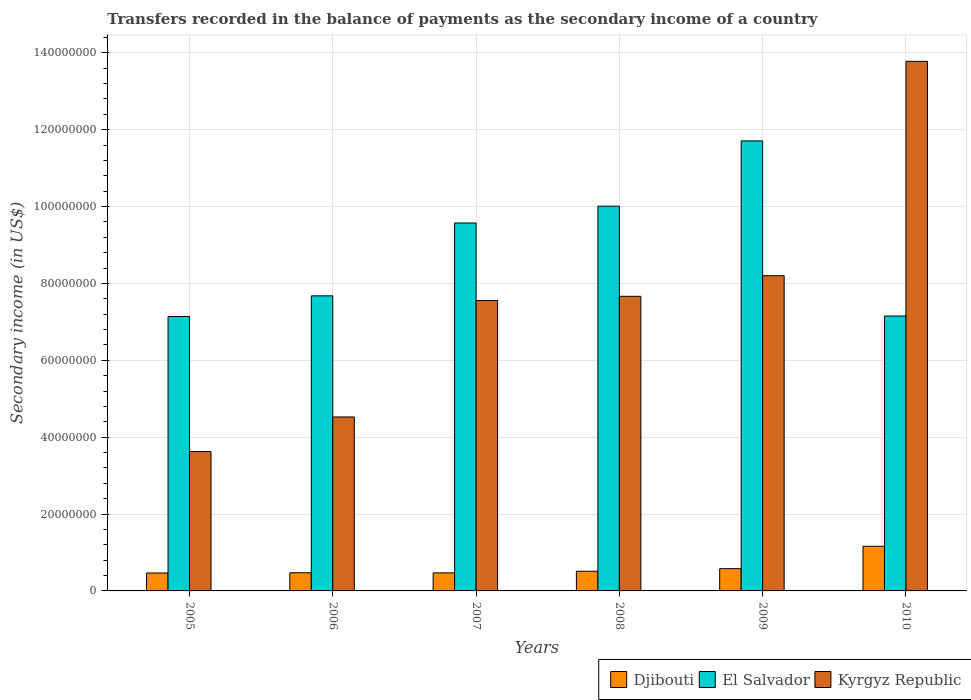How many different coloured bars are there?
Make the answer very short. 3. Are the number of bars on each tick of the X-axis equal?
Your answer should be compact. Yes. How many bars are there on the 1st tick from the right?
Ensure brevity in your answer.  3. What is the label of the 1st group of bars from the left?
Your answer should be compact. 2005. What is the secondary income of in Djibouti in 2007?
Give a very brief answer. 4.70e+06. Across all years, what is the maximum secondary income of in El Salvador?
Ensure brevity in your answer.  1.17e+08. Across all years, what is the minimum secondary income of in El Salvador?
Offer a very short reply. 7.14e+07. What is the total secondary income of in Djibouti in the graph?
Provide a short and direct response. 3.66e+07. What is the difference between the secondary income of in Kyrgyz Republic in 2007 and that in 2010?
Your answer should be very brief. -6.22e+07. What is the difference between the secondary income of in El Salvador in 2008 and the secondary income of in Djibouti in 2007?
Give a very brief answer. 9.54e+07. What is the average secondary income of in Djibouti per year?
Your answer should be compact. 6.10e+06. In the year 2006, what is the difference between the secondary income of in El Salvador and secondary income of in Kyrgyz Republic?
Your response must be concise. 3.15e+07. What is the ratio of the secondary income of in El Salvador in 2007 to that in 2008?
Give a very brief answer. 0.96. Is the difference between the secondary income of in El Salvador in 2005 and 2006 greater than the difference between the secondary income of in Kyrgyz Republic in 2005 and 2006?
Give a very brief answer. Yes. What is the difference between the highest and the second highest secondary income of in Kyrgyz Republic?
Provide a short and direct response. 5.58e+07. What is the difference between the highest and the lowest secondary income of in Djibouti?
Offer a terse response. 6.95e+06. In how many years, is the secondary income of in Djibouti greater than the average secondary income of in Djibouti taken over all years?
Offer a very short reply. 1. Is the sum of the secondary income of in El Salvador in 2005 and 2010 greater than the maximum secondary income of in Djibouti across all years?
Offer a terse response. Yes. What does the 3rd bar from the left in 2006 represents?
Your answer should be compact. Kyrgyz Republic. What does the 2nd bar from the right in 2005 represents?
Your response must be concise. El Salvador. Are all the bars in the graph horizontal?
Your answer should be very brief. No. How many years are there in the graph?
Provide a succinct answer. 6. How many legend labels are there?
Make the answer very short. 3. How are the legend labels stacked?
Give a very brief answer. Horizontal. What is the title of the graph?
Ensure brevity in your answer.  Transfers recorded in the balance of payments as the secondary income of a country. Does "Kuwait" appear as one of the legend labels in the graph?
Give a very brief answer. No. What is the label or title of the X-axis?
Your answer should be compact. Years. What is the label or title of the Y-axis?
Give a very brief answer. Secondary income (in US$). What is the Secondary income (in US$) in Djibouti in 2005?
Your answer should be very brief. 4.67e+06. What is the Secondary income (in US$) of El Salvador in 2005?
Your answer should be very brief. 7.14e+07. What is the Secondary income (in US$) in Kyrgyz Republic in 2005?
Provide a succinct answer. 3.63e+07. What is the Secondary income (in US$) in Djibouti in 2006?
Your answer should be compact. 4.73e+06. What is the Secondary income (in US$) of El Salvador in 2006?
Your answer should be compact. 7.68e+07. What is the Secondary income (in US$) in Kyrgyz Republic in 2006?
Your answer should be very brief. 4.53e+07. What is the Secondary income (in US$) in Djibouti in 2007?
Provide a short and direct response. 4.70e+06. What is the Secondary income (in US$) of El Salvador in 2007?
Your answer should be compact. 9.57e+07. What is the Secondary income (in US$) in Kyrgyz Republic in 2007?
Your answer should be compact. 7.56e+07. What is the Secondary income (in US$) of Djibouti in 2008?
Provide a succinct answer. 5.12e+06. What is the Secondary income (in US$) of El Salvador in 2008?
Make the answer very short. 1.00e+08. What is the Secondary income (in US$) in Kyrgyz Republic in 2008?
Provide a succinct answer. 7.67e+07. What is the Secondary income (in US$) in Djibouti in 2009?
Your response must be concise. 5.79e+06. What is the Secondary income (in US$) of El Salvador in 2009?
Offer a very short reply. 1.17e+08. What is the Secondary income (in US$) in Kyrgyz Republic in 2009?
Your response must be concise. 8.20e+07. What is the Secondary income (in US$) of Djibouti in 2010?
Provide a short and direct response. 1.16e+07. What is the Secondary income (in US$) in El Salvador in 2010?
Ensure brevity in your answer.  7.15e+07. What is the Secondary income (in US$) in Kyrgyz Republic in 2010?
Provide a short and direct response. 1.38e+08. Across all years, what is the maximum Secondary income (in US$) of Djibouti?
Provide a short and direct response. 1.16e+07. Across all years, what is the maximum Secondary income (in US$) in El Salvador?
Offer a very short reply. 1.17e+08. Across all years, what is the maximum Secondary income (in US$) of Kyrgyz Republic?
Give a very brief answer. 1.38e+08. Across all years, what is the minimum Secondary income (in US$) in Djibouti?
Provide a short and direct response. 4.67e+06. Across all years, what is the minimum Secondary income (in US$) in El Salvador?
Give a very brief answer. 7.14e+07. Across all years, what is the minimum Secondary income (in US$) of Kyrgyz Republic?
Your answer should be very brief. 3.63e+07. What is the total Secondary income (in US$) in Djibouti in the graph?
Make the answer very short. 3.66e+07. What is the total Secondary income (in US$) of El Salvador in the graph?
Your answer should be compact. 5.33e+08. What is the total Secondary income (in US$) in Kyrgyz Republic in the graph?
Your answer should be very brief. 4.54e+08. What is the difference between the Secondary income (in US$) of Djibouti in 2005 and that in 2006?
Provide a short and direct response. -5.63e+04. What is the difference between the Secondary income (in US$) of El Salvador in 2005 and that in 2006?
Provide a short and direct response. -5.38e+06. What is the difference between the Secondary income (in US$) in Kyrgyz Republic in 2005 and that in 2006?
Offer a terse response. -8.99e+06. What is the difference between the Secondary income (in US$) of Djibouti in 2005 and that in 2007?
Provide a succinct answer. -2.81e+04. What is the difference between the Secondary income (in US$) in El Salvador in 2005 and that in 2007?
Provide a short and direct response. -2.43e+07. What is the difference between the Secondary income (in US$) in Kyrgyz Republic in 2005 and that in 2007?
Give a very brief answer. -3.93e+07. What is the difference between the Secondary income (in US$) in Djibouti in 2005 and that in 2008?
Offer a very short reply. -4.50e+05. What is the difference between the Secondary income (in US$) in El Salvador in 2005 and that in 2008?
Ensure brevity in your answer.  -2.87e+07. What is the difference between the Secondary income (in US$) of Kyrgyz Republic in 2005 and that in 2008?
Provide a short and direct response. -4.04e+07. What is the difference between the Secondary income (in US$) in Djibouti in 2005 and that in 2009?
Give a very brief answer. -1.12e+06. What is the difference between the Secondary income (in US$) of El Salvador in 2005 and that in 2009?
Offer a terse response. -4.57e+07. What is the difference between the Secondary income (in US$) in Kyrgyz Republic in 2005 and that in 2009?
Offer a very short reply. -4.57e+07. What is the difference between the Secondary income (in US$) in Djibouti in 2005 and that in 2010?
Make the answer very short. -6.95e+06. What is the difference between the Secondary income (in US$) of El Salvador in 2005 and that in 2010?
Your answer should be very brief. -1.23e+05. What is the difference between the Secondary income (in US$) in Kyrgyz Republic in 2005 and that in 2010?
Ensure brevity in your answer.  -1.02e+08. What is the difference between the Secondary income (in US$) in Djibouti in 2006 and that in 2007?
Make the answer very short. 2.81e+04. What is the difference between the Secondary income (in US$) in El Salvador in 2006 and that in 2007?
Offer a terse response. -1.90e+07. What is the difference between the Secondary income (in US$) in Kyrgyz Republic in 2006 and that in 2007?
Ensure brevity in your answer.  -3.03e+07. What is the difference between the Secondary income (in US$) of Djibouti in 2006 and that in 2008?
Offer a terse response. -3.94e+05. What is the difference between the Secondary income (in US$) in El Salvador in 2006 and that in 2008?
Make the answer very short. -2.33e+07. What is the difference between the Secondary income (in US$) of Kyrgyz Republic in 2006 and that in 2008?
Provide a succinct answer. -3.14e+07. What is the difference between the Secondary income (in US$) in Djibouti in 2006 and that in 2009?
Provide a short and direct response. -1.06e+06. What is the difference between the Secondary income (in US$) in El Salvador in 2006 and that in 2009?
Your response must be concise. -4.03e+07. What is the difference between the Secondary income (in US$) in Kyrgyz Republic in 2006 and that in 2009?
Offer a very short reply. -3.68e+07. What is the difference between the Secondary income (in US$) of Djibouti in 2006 and that in 2010?
Your answer should be very brief. -6.89e+06. What is the difference between the Secondary income (in US$) in El Salvador in 2006 and that in 2010?
Offer a very short reply. 5.26e+06. What is the difference between the Secondary income (in US$) in Kyrgyz Republic in 2006 and that in 2010?
Keep it short and to the point. -9.25e+07. What is the difference between the Secondary income (in US$) of Djibouti in 2007 and that in 2008?
Your answer should be very brief. -4.22e+05. What is the difference between the Secondary income (in US$) of El Salvador in 2007 and that in 2008?
Provide a short and direct response. -4.37e+06. What is the difference between the Secondary income (in US$) of Kyrgyz Republic in 2007 and that in 2008?
Keep it short and to the point. -1.10e+06. What is the difference between the Secondary income (in US$) of Djibouti in 2007 and that in 2009?
Offer a terse response. -1.09e+06. What is the difference between the Secondary income (in US$) of El Salvador in 2007 and that in 2009?
Your answer should be very brief. -2.14e+07. What is the difference between the Secondary income (in US$) in Kyrgyz Republic in 2007 and that in 2009?
Offer a terse response. -6.46e+06. What is the difference between the Secondary income (in US$) of Djibouti in 2007 and that in 2010?
Your answer should be compact. -6.92e+06. What is the difference between the Secondary income (in US$) of El Salvador in 2007 and that in 2010?
Keep it short and to the point. 2.42e+07. What is the difference between the Secondary income (in US$) of Kyrgyz Republic in 2007 and that in 2010?
Offer a very short reply. -6.22e+07. What is the difference between the Secondary income (in US$) of Djibouti in 2008 and that in 2009?
Make the answer very short. -6.70e+05. What is the difference between the Secondary income (in US$) of El Salvador in 2008 and that in 2009?
Give a very brief answer. -1.70e+07. What is the difference between the Secondary income (in US$) of Kyrgyz Republic in 2008 and that in 2009?
Provide a succinct answer. -5.35e+06. What is the difference between the Secondary income (in US$) of Djibouti in 2008 and that in 2010?
Give a very brief answer. -6.50e+06. What is the difference between the Secondary income (in US$) of El Salvador in 2008 and that in 2010?
Offer a terse response. 2.86e+07. What is the difference between the Secondary income (in US$) of Kyrgyz Republic in 2008 and that in 2010?
Your answer should be very brief. -6.11e+07. What is the difference between the Secondary income (in US$) of Djibouti in 2009 and that in 2010?
Keep it short and to the point. -5.83e+06. What is the difference between the Secondary income (in US$) in El Salvador in 2009 and that in 2010?
Your response must be concise. 4.56e+07. What is the difference between the Secondary income (in US$) in Kyrgyz Republic in 2009 and that in 2010?
Ensure brevity in your answer.  -5.58e+07. What is the difference between the Secondary income (in US$) of Djibouti in 2005 and the Secondary income (in US$) of El Salvador in 2006?
Provide a succinct answer. -7.21e+07. What is the difference between the Secondary income (in US$) of Djibouti in 2005 and the Secondary income (in US$) of Kyrgyz Republic in 2006?
Provide a short and direct response. -4.06e+07. What is the difference between the Secondary income (in US$) of El Salvador in 2005 and the Secondary income (in US$) of Kyrgyz Republic in 2006?
Ensure brevity in your answer.  2.61e+07. What is the difference between the Secondary income (in US$) in Djibouti in 2005 and the Secondary income (in US$) in El Salvador in 2007?
Your answer should be compact. -9.11e+07. What is the difference between the Secondary income (in US$) of Djibouti in 2005 and the Secondary income (in US$) of Kyrgyz Republic in 2007?
Your response must be concise. -7.09e+07. What is the difference between the Secondary income (in US$) in El Salvador in 2005 and the Secondary income (in US$) in Kyrgyz Republic in 2007?
Give a very brief answer. -4.16e+06. What is the difference between the Secondary income (in US$) in Djibouti in 2005 and the Secondary income (in US$) in El Salvador in 2008?
Keep it short and to the point. -9.54e+07. What is the difference between the Secondary income (in US$) in Djibouti in 2005 and the Secondary income (in US$) in Kyrgyz Republic in 2008?
Provide a succinct answer. -7.20e+07. What is the difference between the Secondary income (in US$) in El Salvador in 2005 and the Secondary income (in US$) in Kyrgyz Republic in 2008?
Make the answer very short. -5.26e+06. What is the difference between the Secondary income (in US$) in Djibouti in 2005 and the Secondary income (in US$) in El Salvador in 2009?
Make the answer very short. -1.12e+08. What is the difference between the Secondary income (in US$) of Djibouti in 2005 and the Secondary income (in US$) of Kyrgyz Republic in 2009?
Offer a terse response. -7.73e+07. What is the difference between the Secondary income (in US$) in El Salvador in 2005 and the Secondary income (in US$) in Kyrgyz Republic in 2009?
Ensure brevity in your answer.  -1.06e+07. What is the difference between the Secondary income (in US$) of Djibouti in 2005 and the Secondary income (in US$) of El Salvador in 2010?
Give a very brief answer. -6.69e+07. What is the difference between the Secondary income (in US$) of Djibouti in 2005 and the Secondary income (in US$) of Kyrgyz Republic in 2010?
Keep it short and to the point. -1.33e+08. What is the difference between the Secondary income (in US$) in El Salvador in 2005 and the Secondary income (in US$) in Kyrgyz Republic in 2010?
Your response must be concise. -6.64e+07. What is the difference between the Secondary income (in US$) of Djibouti in 2006 and the Secondary income (in US$) of El Salvador in 2007?
Your answer should be very brief. -9.10e+07. What is the difference between the Secondary income (in US$) of Djibouti in 2006 and the Secondary income (in US$) of Kyrgyz Republic in 2007?
Give a very brief answer. -7.08e+07. What is the difference between the Secondary income (in US$) in El Salvador in 2006 and the Secondary income (in US$) in Kyrgyz Republic in 2007?
Your response must be concise. 1.22e+06. What is the difference between the Secondary income (in US$) of Djibouti in 2006 and the Secondary income (in US$) of El Salvador in 2008?
Give a very brief answer. -9.54e+07. What is the difference between the Secondary income (in US$) of Djibouti in 2006 and the Secondary income (in US$) of Kyrgyz Republic in 2008?
Your answer should be compact. -7.19e+07. What is the difference between the Secondary income (in US$) of El Salvador in 2006 and the Secondary income (in US$) of Kyrgyz Republic in 2008?
Ensure brevity in your answer.  1.15e+05. What is the difference between the Secondary income (in US$) in Djibouti in 2006 and the Secondary income (in US$) in El Salvador in 2009?
Your answer should be compact. -1.12e+08. What is the difference between the Secondary income (in US$) in Djibouti in 2006 and the Secondary income (in US$) in Kyrgyz Republic in 2009?
Provide a succinct answer. -7.73e+07. What is the difference between the Secondary income (in US$) of El Salvador in 2006 and the Secondary income (in US$) of Kyrgyz Republic in 2009?
Provide a succinct answer. -5.24e+06. What is the difference between the Secondary income (in US$) of Djibouti in 2006 and the Secondary income (in US$) of El Salvador in 2010?
Give a very brief answer. -6.68e+07. What is the difference between the Secondary income (in US$) in Djibouti in 2006 and the Secondary income (in US$) in Kyrgyz Republic in 2010?
Offer a very short reply. -1.33e+08. What is the difference between the Secondary income (in US$) of El Salvador in 2006 and the Secondary income (in US$) of Kyrgyz Republic in 2010?
Provide a short and direct response. -6.10e+07. What is the difference between the Secondary income (in US$) in Djibouti in 2007 and the Secondary income (in US$) in El Salvador in 2008?
Your answer should be very brief. -9.54e+07. What is the difference between the Secondary income (in US$) of Djibouti in 2007 and the Secondary income (in US$) of Kyrgyz Republic in 2008?
Offer a very short reply. -7.20e+07. What is the difference between the Secondary income (in US$) in El Salvador in 2007 and the Secondary income (in US$) in Kyrgyz Republic in 2008?
Give a very brief answer. 1.91e+07. What is the difference between the Secondary income (in US$) in Djibouti in 2007 and the Secondary income (in US$) in El Salvador in 2009?
Provide a short and direct response. -1.12e+08. What is the difference between the Secondary income (in US$) in Djibouti in 2007 and the Secondary income (in US$) in Kyrgyz Republic in 2009?
Your answer should be very brief. -7.73e+07. What is the difference between the Secondary income (in US$) of El Salvador in 2007 and the Secondary income (in US$) of Kyrgyz Republic in 2009?
Your response must be concise. 1.37e+07. What is the difference between the Secondary income (in US$) of Djibouti in 2007 and the Secondary income (in US$) of El Salvador in 2010?
Give a very brief answer. -6.68e+07. What is the difference between the Secondary income (in US$) of Djibouti in 2007 and the Secondary income (in US$) of Kyrgyz Republic in 2010?
Offer a terse response. -1.33e+08. What is the difference between the Secondary income (in US$) in El Salvador in 2007 and the Secondary income (in US$) in Kyrgyz Republic in 2010?
Your answer should be compact. -4.21e+07. What is the difference between the Secondary income (in US$) in Djibouti in 2008 and the Secondary income (in US$) in El Salvador in 2009?
Your response must be concise. -1.12e+08. What is the difference between the Secondary income (in US$) of Djibouti in 2008 and the Secondary income (in US$) of Kyrgyz Republic in 2009?
Offer a very short reply. -7.69e+07. What is the difference between the Secondary income (in US$) of El Salvador in 2008 and the Secondary income (in US$) of Kyrgyz Republic in 2009?
Give a very brief answer. 1.81e+07. What is the difference between the Secondary income (in US$) of Djibouti in 2008 and the Secondary income (in US$) of El Salvador in 2010?
Provide a succinct answer. -6.64e+07. What is the difference between the Secondary income (in US$) of Djibouti in 2008 and the Secondary income (in US$) of Kyrgyz Republic in 2010?
Provide a succinct answer. -1.33e+08. What is the difference between the Secondary income (in US$) of El Salvador in 2008 and the Secondary income (in US$) of Kyrgyz Republic in 2010?
Your answer should be very brief. -3.77e+07. What is the difference between the Secondary income (in US$) in Djibouti in 2009 and the Secondary income (in US$) in El Salvador in 2010?
Provide a succinct answer. -6.57e+07. What is the difference between the Secondary income (in US$) of Djibouti in 2009 and the Secondary income (in US$) of Kyrgyz Republic in 2010?
Offer a terse response. -1.32e+08. What is the difference between the Secondary income (in US$) in El Salvador in 2009 and the Secondary income (in US$) in Kyrgyz Republic in 2010?
Your answer should be very brief. -2.07e+07. What is the average Secondary income (in US$) of Djibouti per year?
Offer a terse response. 6.10e+06. What is the average Secondary income (in US$) of El Salvador per year?
Your response must be concise. 8.88e+07. What is the average Secondary income (in US$) in Kyrgyz Republic per year?
Give a very brief answer. 7.56e+07. In the year 2005, what is the difference between the Secondary income (in US$) in Djibouti and Secondary income (in US$) in El Salvador?
Keep it short and to the point. -6.67e+07. In the year 2005, what is the difference between the Secondary income (in US$) of Djibouti and Secondary income (in US$) of Kyrgyz Republic?
Provide a succinct answer. -3.16e+07. In the year 2005, what is the difference between the Secondary income (in US$) of El Salvador and Secondary income (in US$) of Kyrgyz Republic?
Make the answer very short. 3.51e+07. In the year 2006, what is the difference between the Secondary income (in US$) of Djibouti and Secondary income (in US$) of El Salvador?
Make the answer very short. -7.21e+07. In the year 2006, what is the difference between the Secondary income (in US$) of Djibouti and Secondary income (in US$) of Kyrgyz Republic?
Your answer should be very brief. -4.05e+07. In the year 2006, what is the difference between the Secondary income (in US$) in El Salvador and Secondary income (in US$) in Kyrgyz Republic?
Offer a terse response. 3.15e+07. In the year 2007, what is the difference between the Secondary income (in US$) of Djibouti and Secondary income (in US$) of El Salvador?
Your answer should be very brief. -9.10e+07. In the year 2007, what is the difference between the Secondary income (in US$) of Djibouti and Secondary income (in US$) of Kyrgyz Republic?
Your response must be concise. -7.09e+07. In the year 2007, what is the difference between the Secondary income (in US$) of El Salvador and Secondary income (in US$) of Kyrgyz Republic?
Provide a succinct answer. 2.02e+07. In the year 2008, what is the difference between the Secondary income (in US$) in Djibouti and Secondary income (in US$) in El Salvador?
Keep it short and to the point. -9.50e+07. In the year 2008, what is the difference between the Secondary income (in US$) of Djibouti and Secondary income (in US$) of Kyrgyz Republic?
Give a very brief answer. -7.15e+07. In the year 2008, what is the difference between the Secondary income (in US$) in El Salvador and Secondary income (in US$) in Kyrgyz Republic?
Offer a terse response. 2.34e+07. In the year 2009, what is the difference between the Secondary income (in US$) of Djibouti and Secondary income (in US$) of El Salvador?
Give a very brief answer. -1.11e+08. In the year 2009, what is the difference between the Secondary income (in US$) of Djibouti and Secondary income (in US$) of Kyrgyz Republic?
Your answer should be compact. -7.62e+07. In the year 2009, what is the difference between the Secondary income (in US$) in El Salvador and Secondary income (in US$) in Kyrgyz Republic?
Provide a short and direct response. 3.51e+07. In the year 2010, what is the difference between the Secondary income (in US$) of Djibouti and Secondary income (in US$) of El Salvador?
Give a very brief answer. -5.99e+07. In the year 2010, what is the difference between the Secondary income (in US$) of Djibouti and Secondary income (in US$) of Kyrgyz Republic?
Your answer should be very brief. -1.26e+08. In the year 2010, what is the difference between the Secondary income (in US$) of El Salvador and Secondary income (in US$) of Kyrgyz Republic?
Provide a succinct answer. -6.63e+07. What is the ratio of the Secondary income (in US$) of Djibouti in 2005 to that in 2006?
Your answer should be compact. 0.99. What is the ratio of the Secondary income (in US$) in El Salvador in 2005 to that in 2006?
Give a very brief answer. 0.93. What is the ratio of the Secondary income (in US$) of Kyrgyz Republic in 2005 to that in 2006?
Provide a short and direct response. 0.8. What is the ratio of the Secondary income (in US$) in Djibouti in 2005 to that in 2007?
Keep it short and to the point. 0.99. What is the ratio of the Secondary income (in US$) of El Salvador in 2005 to that in 2007?
Your response must be concise. 0.75. What is the ratio of the Secondary income (in US$) of Kyrgyz Republic in 2005 to that in 2007?
Offer a very short reply. 0.48. What is the ratio of the Secondary income (in US$) in Djibouti in 2005 to that in 2008?
Make the answer very short. 0.91. What is the ratio of the Secondary income (in US$) of El Salvador in 2005 to that in 2008?
Your answer should be very brief. 0.71. What is the ratio of the Secondary income (in US$) of Kyrgyz Republic in 2005 to that in 2008?
Give a very brief answer. 0.47. What is the ratio of the Secondary income (in US$) of Djibouti in 2005 to that in 2009?
Offer a very short reply. 0.81. What is the ratio of the Secondary income (in US$) in El Salvador in 2005 to that in 2009?
Make the answer very short. 0.61. What is the ratio of the Secondary income (in US$) of Kyrgyz Republic in 2005 to that in 2009?
Offer a very short reply. 0.44. What is the ratio of the Secondary income (in US$) in Djibouti in 2005 to that in 2010?
Your answer should be compact. 0.4. What is the ratio of the Secondary income (in US$) in Kyrgyz Republic in 2005 to that in 2010?
Keep it short and to the point. 0.26. What is the ratio of the Secondary income (in US$) of Djibouti in 2006 to that in 2007?
Make the answer very short. 1.01. What is the ratio of the Secondary income (in US$) of El Salvador in 2006 to that in 2007?
Ensure brevity in your answer.  0.8. What is the ratio of the Secondary income (in US$) of Kyrgyz Republic in 2006 to that in 2007?
Provide a succinct answer. 0.6. What is the ratio of the Secondary income (in US$) of Djibouti in 2006 to that in 2008?
Keep it short and to the point. 0.92. What is the ratio of the Secondary income (in US$) in El Salvador in 2006 to that in 2008?
Give a very brief answer. 0.77. What is the ratio of the Secondary income (in US$) in Kyrgyz Republic in 2006 to that in 2008?
Offer a very short reply. 0.59. What is the ratio of the Secondary income (in US$) in Djibouti in 2006 to that in 2009?
Your answer should be compact. 0.82. What is the ratio of the Secondary income (in US$) of El Salvador in 2006 to that in 2009?
Your answer should be compact. 0.66. What is the ratio of the Secondary income (in US$) of Kyrgyz Republic in 2006 to that in 2009?
Keep it short and to the point. 0.55. What is the ratio of the Secondary income (in US$) of Djibouti in 2006 to that in 2010?
Provide a succinct answer. 0.41. What is the ratio of the Secondary income (in US$) of El Salvador in 2006 to that in 2010?
Your answer should be compact. 1.07. What is the ratio of the Secondary income (in US$) of Kyrgyz Republic in 2006 to that in 2010?
Offer a very short reply. 0.33. What is the ratio of the Secondary income (in US$) of Djibouti in 2007 to that in 2008?
Give a very brief answer. 0.92. What is the ratio of the Secondary income (in US$) in El Salvador in 2007 to that in 2008?
Provide a succinct answer. 0.96. What is the ratio of the Secondary income (in US$) in Kyrgyz Republic in 2007 to that in 2008?
Your answer should be compact. 0.99. What is the ratio of the Secondary income (in US$) in Djibouti in 2007 to that in 2009?
Ensure brevity in your answer.  0.81. What is the ratio of the Secondary income (in US$) in El Salvador in 2007 to that in 2009?
Offer a very short reply. 0.82. What is the ratio of the Secondary income (in US$) in Kyrgyz Republic in 2007 to that in 2009?
Offer a very short reply. 0.92. What is the ratio of the Secondary income (in US$) of Djibouti in 2007 to that in 2010?
Offer a terse response. 0.4. What is the ratio of the Secondary income (in US$) of El Salvador in 2007 to that in 2010?
Give a very brief answer. 1.34. What is the ratio of the Secondary income (in US$) in Kyrgyz Republic in 2007 to that in 2010?
Offer a very short reply. 0.55. What is the ratio of the Secondary income (in US$) in Djibouti in 2008 to that in 2009?
Your answer should be compact. 0.88. What is the ratio of the Secondary income (in US$) in El Salvador in 2008 to that in 2009?
Your answer should be very brief. 0.85. What is the ratio of the Secondary income (in US$) of Kyrgyz Republic in 2008 to that in 2009?
Your answer should be very brief. 0.93. What is the ratio of the Secondary income (in US$) of Djibouti in 2008 to that in 2010?
Provide a short and direct response. 0.44. What is the ratio of the Secondary income (in US$) of El Salvador in 2008 to that in 2010?
Ensure brevity in your answer.  1.4. What is the ratio of the Secondary income (in US$) of Kyrgyz Republic in 2008 to that in 2010?
Make the answer very short. 0.56. What is the ratio of the Secondary income (in US$) of Djibouti in 2009 to that in 2010?
Provide a short and direct response. 0.5. What is the ratio of the Secondary income (in US$) in El Salvador in 2009 to that in 2010?
Offer a terse response. 1.64. What is the ratio of the Secondary income (in US$) of Kyrgyz Republic in 2009 to that in 2010?
Ensure brevity in your answer.  0.6. What is the difference between the highest and the second highest Secondary income (in US$) of Djibouti?
Provide a succinct answer. 5.83e+06. What is the difference between the highest and the second highest Secondary income (in US$) of El Salvador?
Keep it short and to the point. 1.70e+07. What is the difference between the highest and the second highest Secondary income (in US$) in Kyrgyz Republic?
Provide a short and direct response. 5.58e+07. What is the difference between the highest and the lowest Secondary income (in US$) in Djibouti?
Give a very brief answer. 6.95e+06. What is the difference between the highest and the lowest Secondary income (in US$) in El Salvador?
Offer a terse response. 4.57e+07. What is the difference between the highest and the lowest Secondary income (in US$) of Kyrgyz Republic?
Your response must be concise. 1.02e+08. 